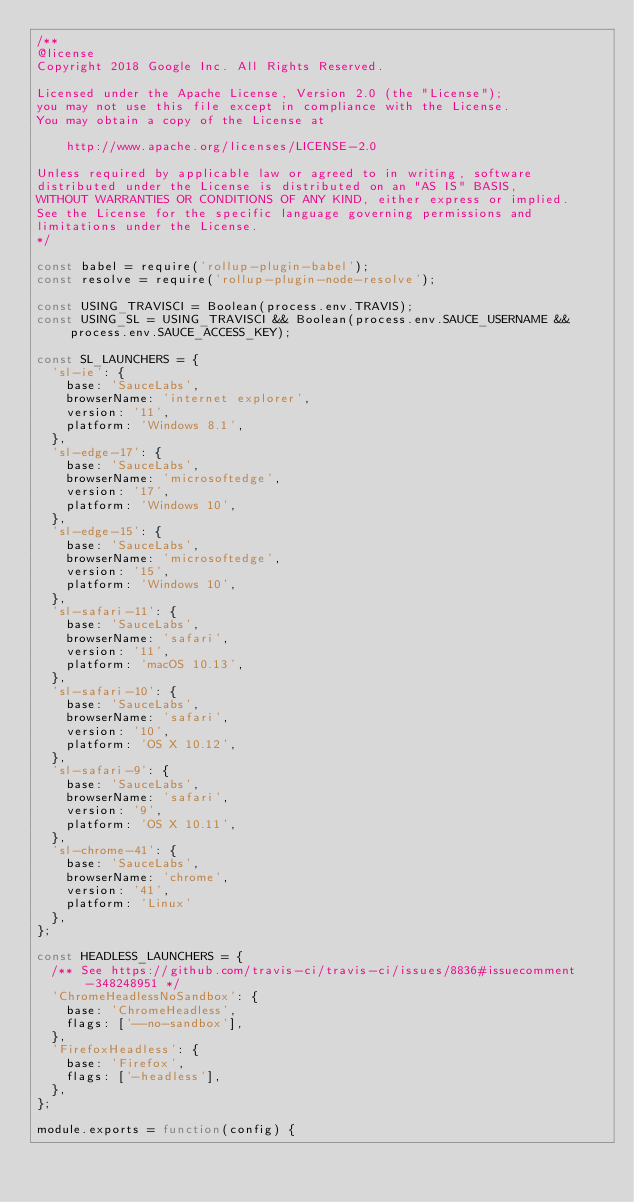<code> <loc_0><loc_0><loc_500><loc_500><_JavaScript_>/**
@license
Copyright 2018 Google Inc. All Rights Reserved.

Licensed under the Apache License, Version 2.0 (the "License");
you may not use this file except in compliance with the License.
You may obtain a copy of the License at

    http://www.apache.org/licenses/LICENSE-2.0

Unless required by applicable law or agreed to in writing, software
distributed under the License is distributed on an "AS IS" BASIS,
WITHOUT WARRANTIES OR CONDITIONS OF ANY KIND, either express or implied.
See the License for the specific language governing permissions and
limitations under the License.
*/

const babel = require('rollup-plugin-babel');
const resolve = require('rollup-plugin-node-resolve');

const USING_TRAVISCI = Boolean(process.env.TRAVIS);
const USING_SL = USING_TRAVISCI && Boolean(process.env.SAUCE_USERNAME && process.env.SAUCE_ACCESS_KEY);

const SL_LAUNCHERS = {
  'sl-ie': {
    base: 'SauceLabs',
    browserName: 'internet explorer',
    version: '11',
    platform: 'Windows 8.1',
  },
  'sl-edge-17': {
    base: 'SauceLabs',
    browserName: 'microsoftedge',
    version: '17',
    platform: 'Windows 10',
  },
  'sl-edge-15': {
    base: 'SauceLabs',
    browserName: 'microsoftedge',
    version: '15',
    platform: 'Windows 10',
  },
  'sl-safari-11': {
    base: 'SauceLabs',
    browserName: 'safari',
    version: '11',
    platform: 'macOS 10.13',
  },
  'sl-safari-10': {
    base: 'SauceLabs',
    browserName: 'safari',
    version: '10',
    platform: 'OS X 10.12',
  },
  'sl-safari-9': {
    base: 'SauceLabs',
    browserName: 'safari',
    version: '9',
    platform: 'OS X 10.11',
  },
  'sl-chrome-41': {
    base: 'SauceLabs',
    browserName: 'chrome',
    version: '41',
    platform: 'Linux'
  },
};

const HEADLESS_LAUNCHERS = {
  /** See https://github.com/travis-ci/travis-ci/issues/8836#issuecomment-348248951 */
  'ChromeHeadlessNoSandbox': {
    base: 'ChromeHeadless',
    flags: ['--no-sandbox'],
  },
  'FirefoxHeadless': {
    base: 'Firefox',
    flags: ['-headless'],
  },
};

module.exports = function(config) {</code> 